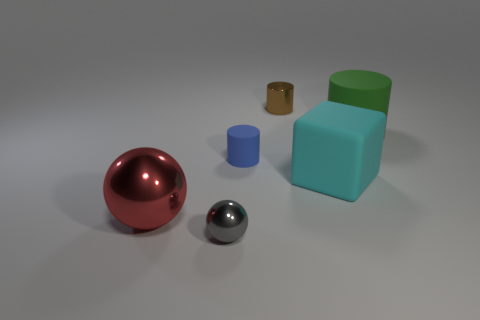Subtract all green rubber cylinders. How many cylinders are left? 2 Add 3 big cyan blocks. How many objects exist? 9 Subtract all spheres. How many objects are left? 4 Subtract all tiny cyan matte spheres. Subtract all big cylinders. How many objects are left? 5 Add 6 tiny matte things. How many tiny matte things are left? 7 Add 6 tiny purple objects. How many tiny purple objects exist? 6 Subtract 0 yellow balls. How many objects are left? 6 